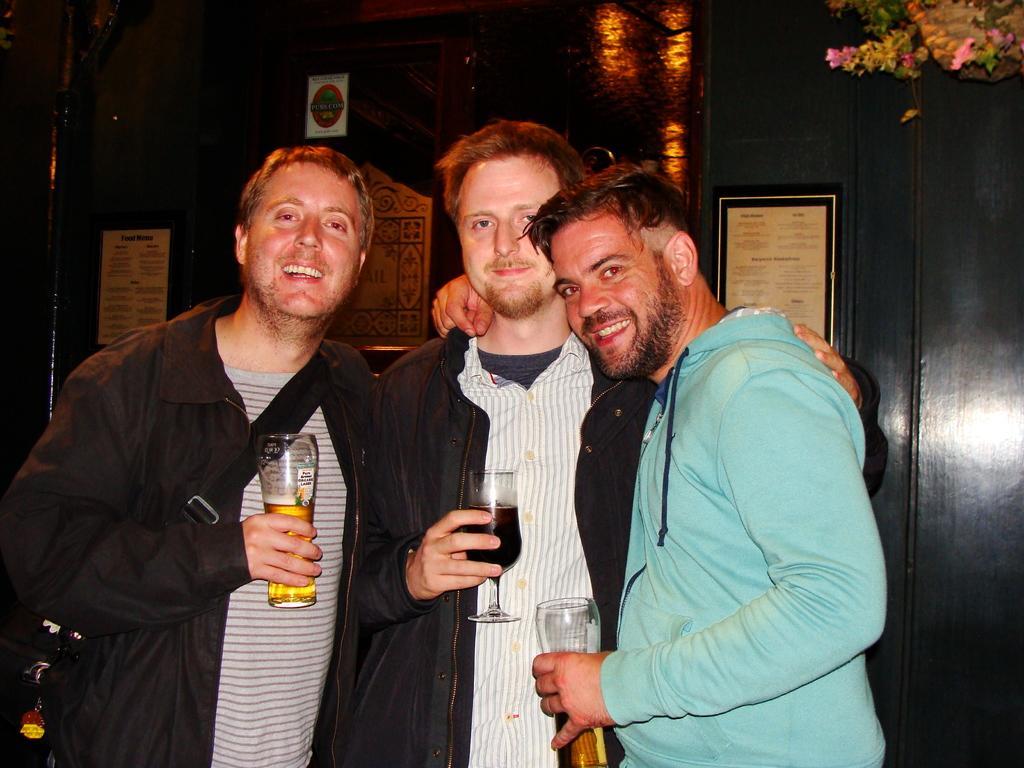Can you describe this image briefly? In this image there are three persons who are standing and these three persons are holding glasses and that glasses are filled with some drink. On the right side one person who is standing is wearing a blue shirt and on the left side one person is standing who is wearing a black shirt and white striped t shirt and he is wearing one bag pack. Between them another person is is standing and he is holding a glass. Behind these persons there is one wall and there is one frame. On the top of the right corner there is one flower pot. 